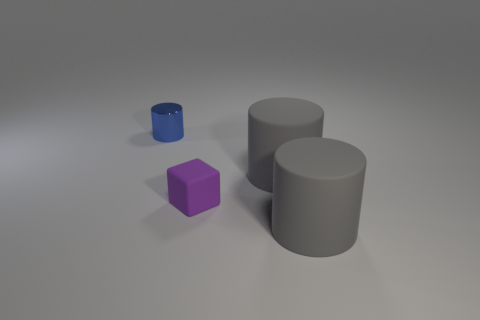Subtract all small blue shiny cylinders. How many cylinders are left? 2 Add 3 gray matte cylinders. How many objects exist? 7 Subtract all gray cylinders. How many cylinders are left? 1 Subtract 1 cylinders. How many cylinders are left? 2 Subtract all blocks. How many objects are left? 3 Subtract all brown blocks. Subtract all blue cylinders. How many blocks are left? 1 Subtract all yellow spheres. How many blue cylinders are left? 1 Subtract all blue things. Subtract all tiny purple rubber things. How many objects are left? 2 Add 1 gray rubber things. How many gray rubber things are left? 3 Add 2 cylinders. How many cylinders exist? 5 